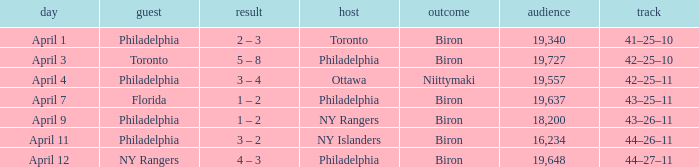Who were the visitors when the home team were the ny rangers? Philadelphia. 